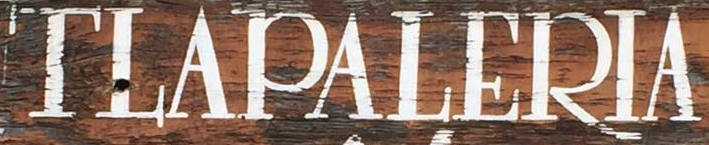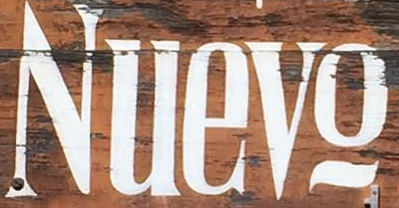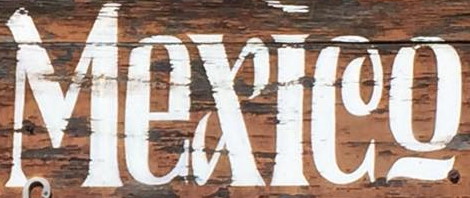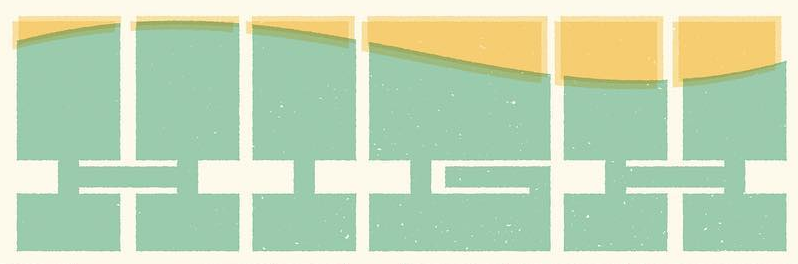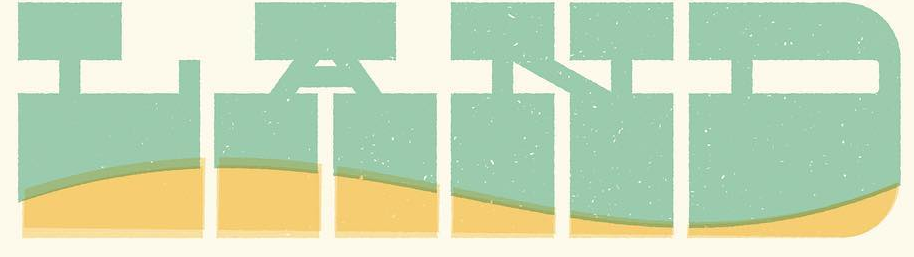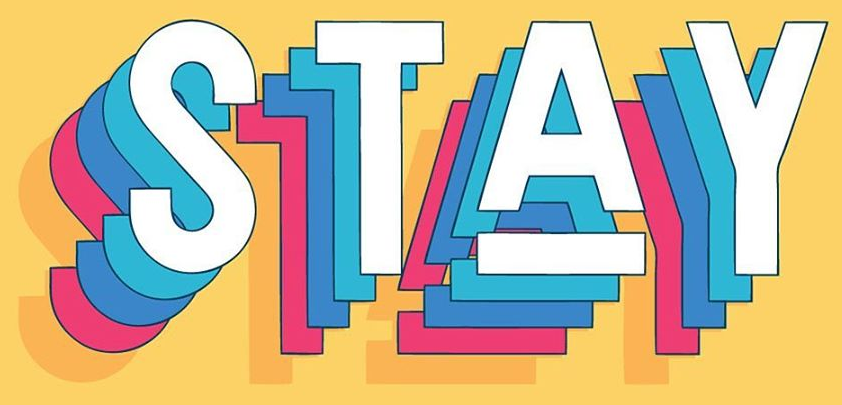Transcribe the words shown in these images in order, separated by a semicolon. TLAPALERIA; Nuevo; Mexleo; HIGH; LAND; STAY 